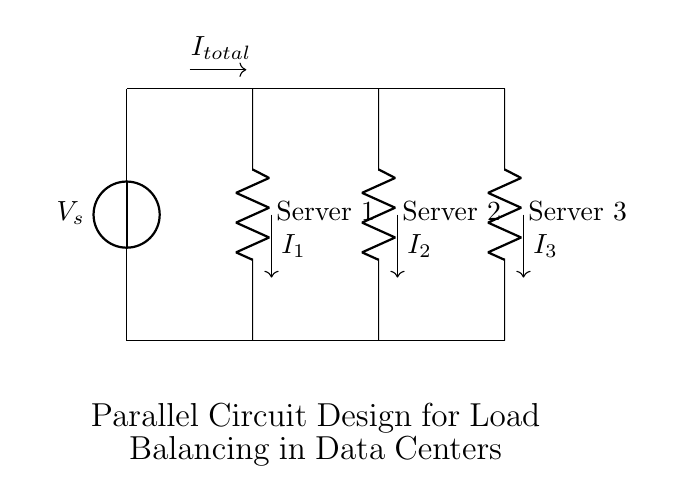What is the total current entering the circuit? The total current entering the circuit is labeled as I total. This is the current provided by the voltage source, which splits among the server racks in the parallel configuration.
Answer: I total What are the components in this parallel circuit? The components in this circuit diagram include the voltage source, three resistors (representing the server racks), and connecting lines. Each resistor is labeled as Server 1, Server 2, and Server 3.
Answer: Voltage source, Server 1, Server 2, Server 3 How many server racks are connected in parallel? There are three server racks connected in parallel, as indicated by the three resistors labeled from Server 1 to Server 3 in the diagram. Each rack draws current from the same voltage source.
Answer: Three What happens to the total current when one server rack fails? If one server rack fails, the total current will still flow through the remaining two racks. The failure of one rack means that the total current will be divided among the two functioning racks after the failure, maintaining overall circuit integrity.
Answer: It divides among remaining racks What is the relationship between the voltage across each server rack? The voltage across each server rack is the same because they are connected in parallel. This means each server receives the same voltage from the source, ensuring balanced operation in a data center.
Answer: Same voltage How does the current division work in this circuit? Current division in this circuit occurs based on the resistance values of each server rack; the total current from the source is divided inversely proportional to the resistance of each rack. Lower resistance results in higher current through that rack.
Answer: Inversely proportional to resistance 